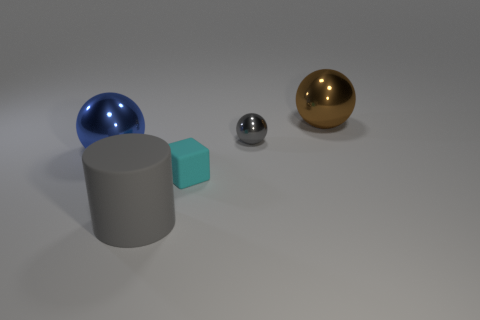Is there a blue sphere made of the same material as the small cyan block?
Ensure brevity in your answer.  No. Does the small rubber block have the same color as the large cylinder?
Make the answer very short. No. There is a object that is to the left of the brown metallic sphere and behind the blue shiny sphere; what is its material?
Keep it short and to the point. Metal. The cube is what color?
Make the answer very short. Cyan. How many cyan matte objects are the same shape as the gray metallic object?
Provide a succinct answer. 0. Is the material of the large sphere in front of the large brown metal object the same as the big object that is in front of the large blue shiny sphere?
Your answer should be compact. No. How big is the gray thing that is in front of the sphere that is to the left of the big gray thing?
Your answer should be compact. Large. Is there anything else that has the same size as the gray rubber cylinder?
Provide a succinct answer. Yes. There is a tiny gray object that is the same shape as the blue object; what is its material?
Your answer should be very brief. Metal. There is a big shiny thing that is on the left side of the big gray rubber object; is it the same shape as the object in front of the small cyan thing?
Offer a terse response. No. 